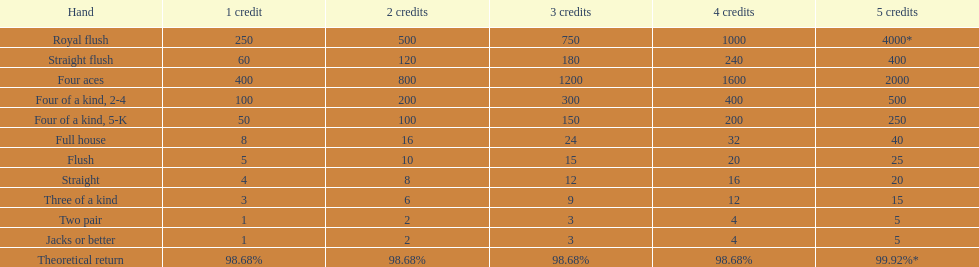What's the best type of four of a kind to win? Four of a kind, 2-4. 